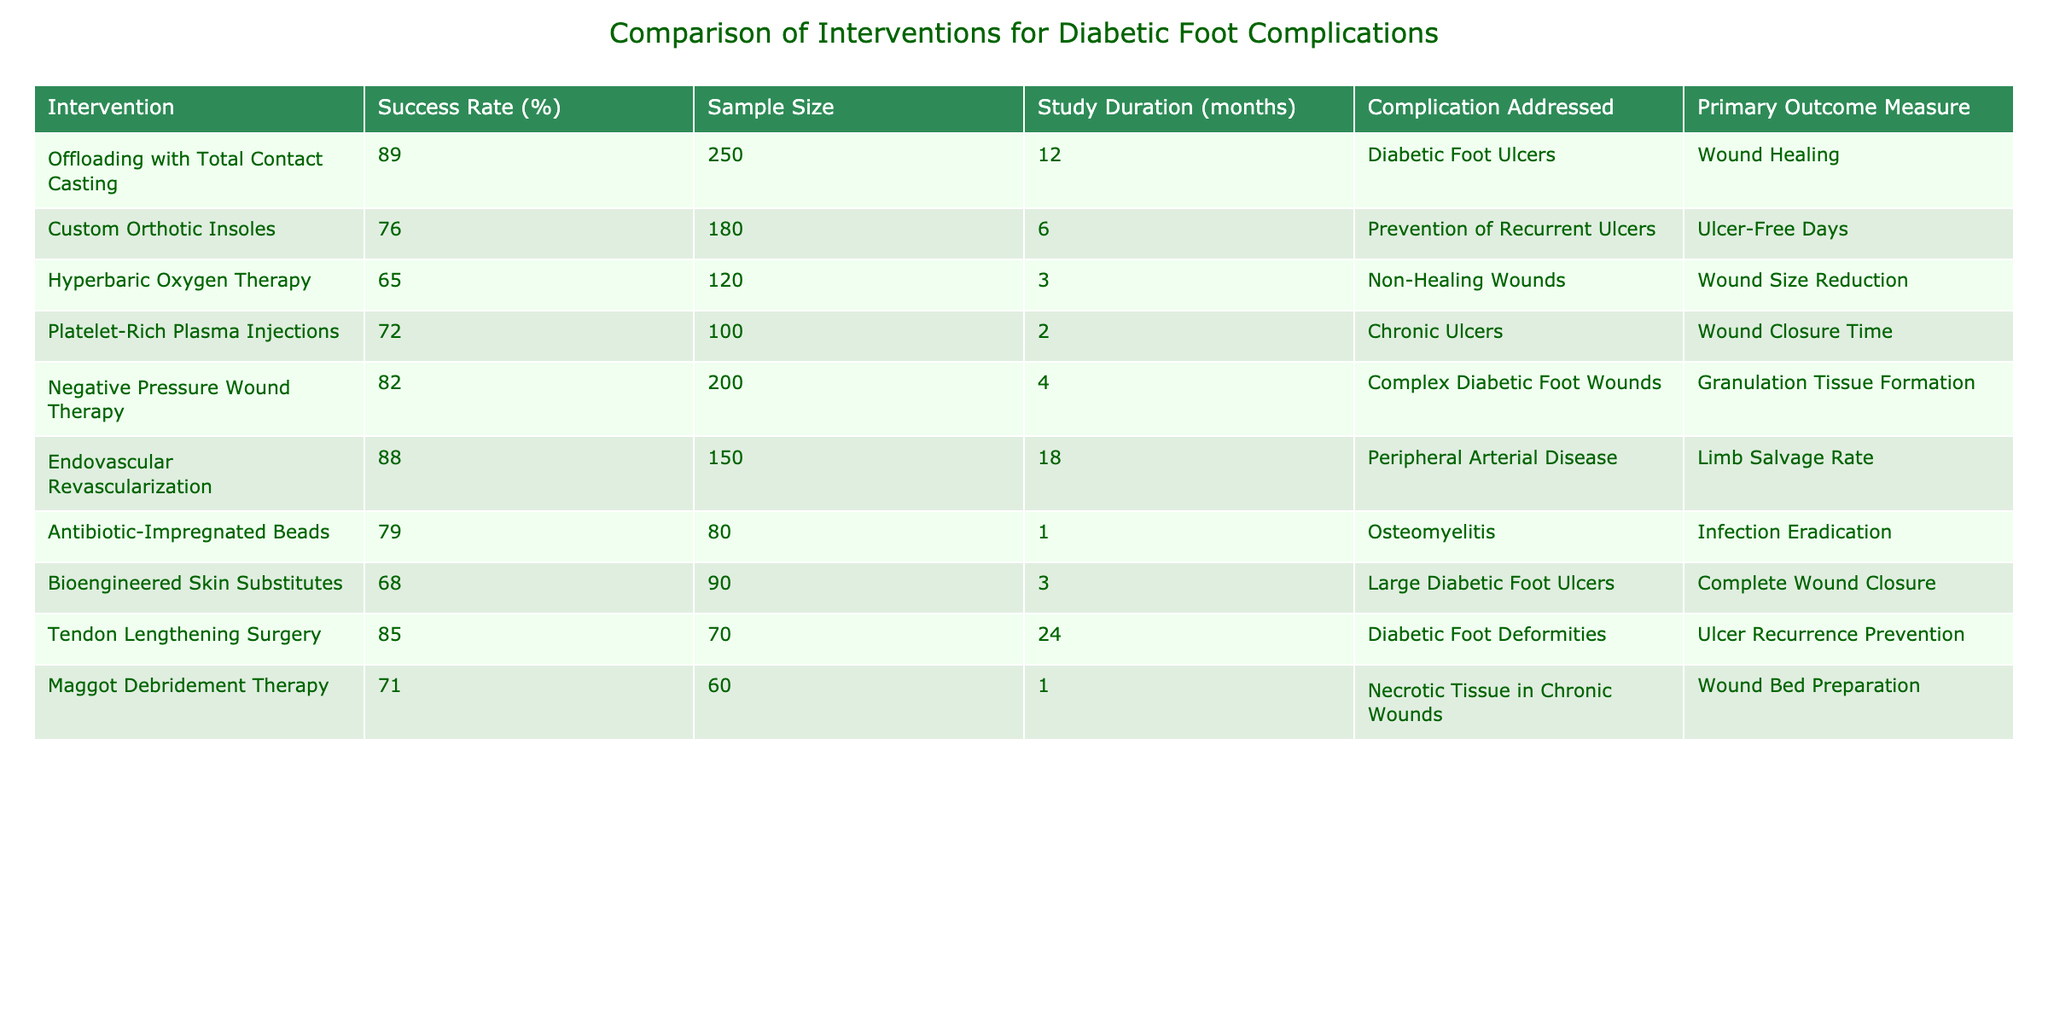What is the success rate for Offloading with Total Contact Casting? The table lists the success rate for this intervention under the column "Success Rate (%)", which is stated as 89%.
Answer: 89% How many patients were included in the study for Custom Orthotic Insoles? Looking at the "Sample Size" column for Custom Orthotic Insoles, it shows the number of patients as 180.
Answer: 180 Which intervention has the highest success rate for addressing peripheral arterial disease? The "Success Rate (%)" column indicates that Endovascular Revascularization has the highest success rate for this complication, which is 88%.
Answer: 88% What is the average success rate of the interventions listed? To find the average, sum all the success rates (89 + 76 + 65 + 72 + 82 + 88 + 79 + 68 + 85 + 71 =  815) and divide by the total number of interventions (10). Thus, the average is 815 / 10 = 81.5%.
Answer: 81.5% Is the success rate for Antibiotic-Impregnated Beads greater than that of Hyperbaric Oxygen Therapy? Comparing the success rates, Antibiotic-Impregnated Beads is 79% and Hyperbaric Oxygen Therapy is 65%. Since 79% is greater than 65%, the statement is true.
Answer: Yes Which intervention has the shortest study duration and what is its success rate? The "Study Duration (months)" for Maggot Debridement Therapy is 1 month, and its corresponding success rate from the table is 71%.
Answer: 71% If we only consider interventions with a success rate above 80%, how many are there? Checking the success rates, Offloading with Total Contact Casting (89%), Negative Pressure Wound Therapy (82%), and Endovascular Revascularization (88%) all exceed 80%. Therefore, there are three interventions.
Answer: 3 What is the total sample size of interventions that address complex diabetic foot wounds? The relevant interventions are Negative Pressure Wound Therapy and Hyperbaric Oxygen Therapy. Their sample sizes are 200 and 120, respectively. Adding these gives a total of 200 + 120 = 320.
Answer: 320 Which intervention had the lowest reported success rate, and what was that rate? Bioengineered Skin Substitutes had the lowest reported success rate at 68%.
Answer: 68% 